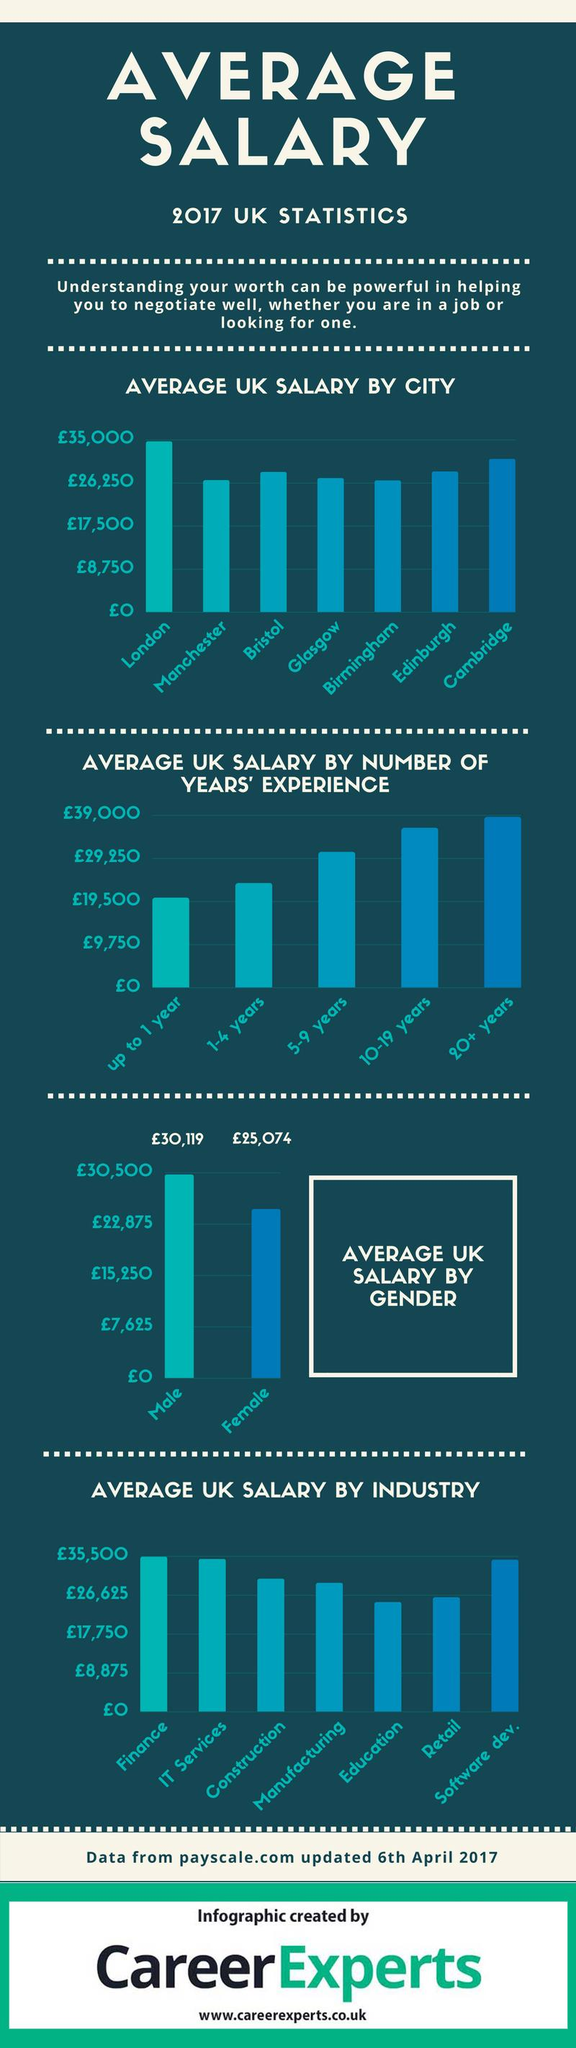Identify some key points in this picture. In the United Kingdom, industries such as education and retail have average salaries that are less than 26,625 pounds. People who have been working in the UK for 10 to 19 years are receiving the second highest salary. Edinburgh, located in the United Kingdom, has the third highest salary among all cities in the UK. There are two categories of experienced people who are receiving a salary less than £29,250. According to recent data, the city of Cambridge in the United Kingdom has the second highest average salary in the country. 